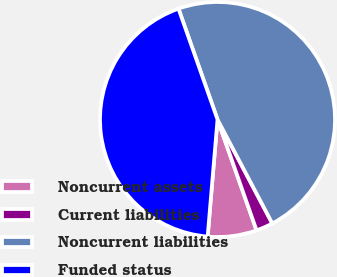Convert chart to OTSL. <chart><loc_0><loc_0><loc_500><loc_500><pie_chart><fcel>Noncurrent assets<fcel>Current liabilities<fcel>Noncurrent liabilities<fcel>Funded status<nl><fcel>6.73%<fcel>2.33%<fcel>47.67%<fcel>43.27%<nl></chart> 